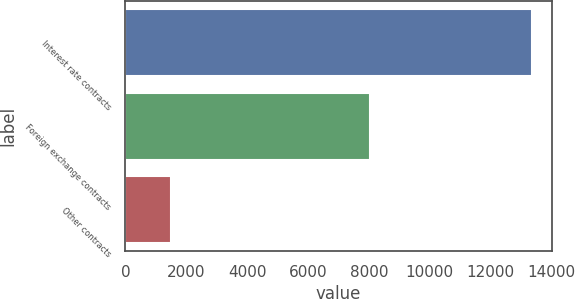Convert chart to OTSL. <chart><loc_0><loc_0><loc_500><loc_500><bar_chart><fcel>Interest rate contracts<fcel>Foreign exchange contracts<fcel>Other contracts<nl><fcel>13350<fcel>8039<fcel>1498<nl></chart> 